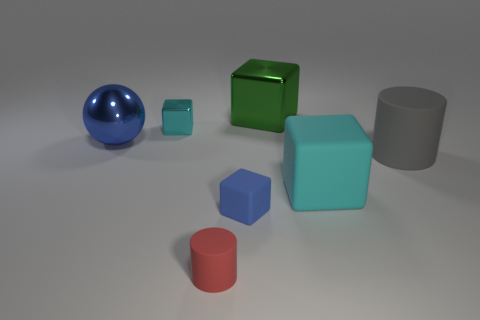Subtract all big green metallic blocks. How many blocks are left? 3 Subtract all purple cylinders. How many cyan cubes are left? 2 Subtract all green blocks. How many blocks are left? 3 Subtract 2 blocks. How many blocks are left? 2 Subtract all cylinders. How many objects are left? 5 Add 1 large rubber blocks. How many objects exist? 8 Subtract all purple cubes. Subtract all brown cylinders. How many cubes are left? 4 Subtract 1 red cylinders. How many objects are left? 6 Subtract all blue metallic objects. Subtract all large balls. How many objects are left? 5 Add 7 gray cylinders. How many gray cylinders are left? 8 